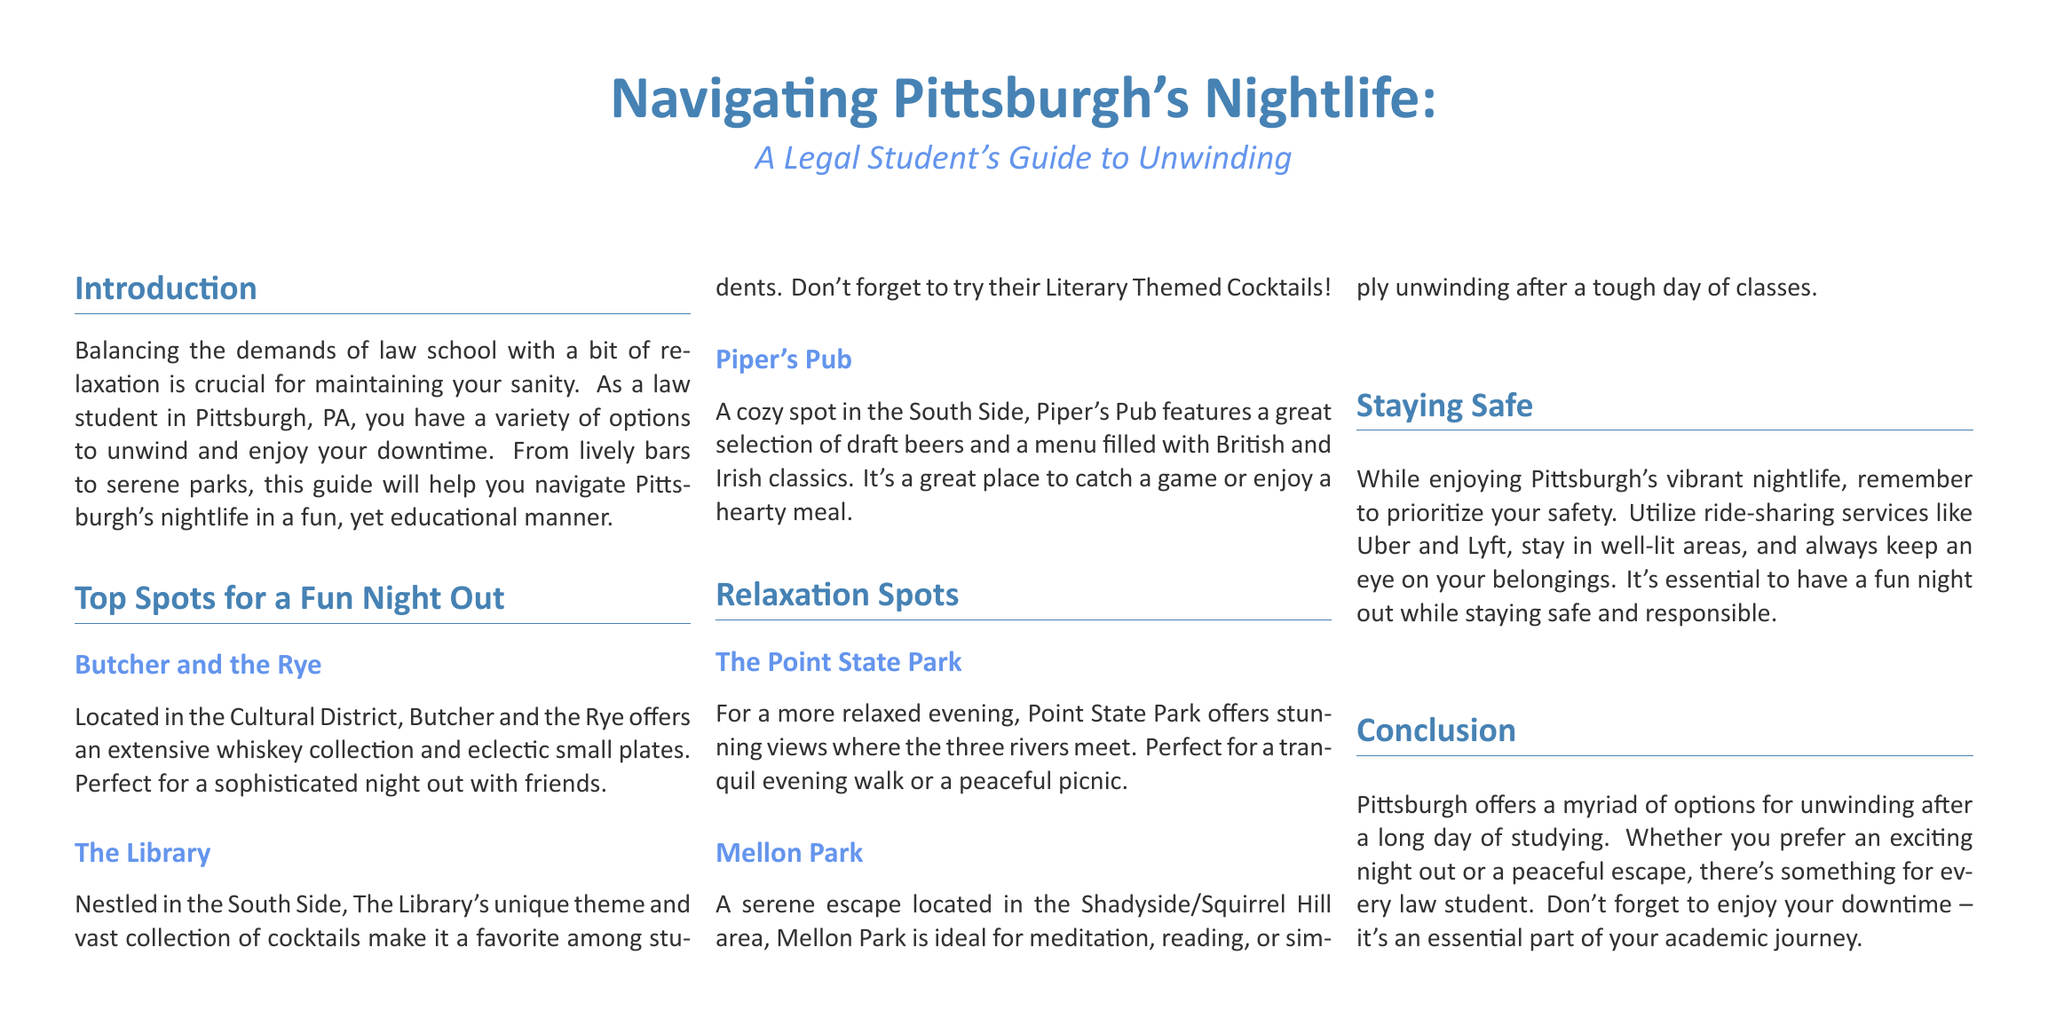What is the title of the guide? The title of the guide is prominently displayed at the top of the document, indicating the focus on Pittsburgh's nightlife for law students.
Answer: Navigating Pittsburgh's Nightlife: A Legal Student's Guide to Unwinding What is one cocktail you can try at The Library? The document mentions the unique theme and vast cocktail selection at The Library, including literary themed cocktails as a specific recommendation.
Answer: Literary Themed Cocktails Which park offers stunning views of where the three rivers meet? The guide specifically names Point State Park as the location with stunning views where the three rivers converge.
Answer: Point State Park What type of cuisine is featured at Piper's Pub? The guide describes the menu at Piper's Pub, highlighting the British and Irish classics offered at this cozy spot.
Answer: British and Irish classics What is a recommended activity for Mellon Park? The document suggests activities like meditation, reading, or unwinding to enjoy in the serene environment of Mellon Park.
Answer: Meditation, reading, or unwinding What should you use for transportation to stay safe at night? The guide recommends using ride-sharing services as a key safety measure when navigating Pittsburgh's nightlife.
Answer: Ride-sharing services How many nightlife categories are mentioned in the guide? The document includes sections for "Top Spots for a Fun Night Out" and "Relaxation Spots," indicating two main categories for nightlife recommendations.
Answer: Two What color is used for section headings in the document? The headings are formatted in a specific color according to the document settings, described as heading color.
Answer: Heading color What is emphasized as essential during a night out? The document stresses the importance of safety and responsibility as essential elements to keep in mind during a night out in Pittsburgh.
Answer: Safety and responsibility 